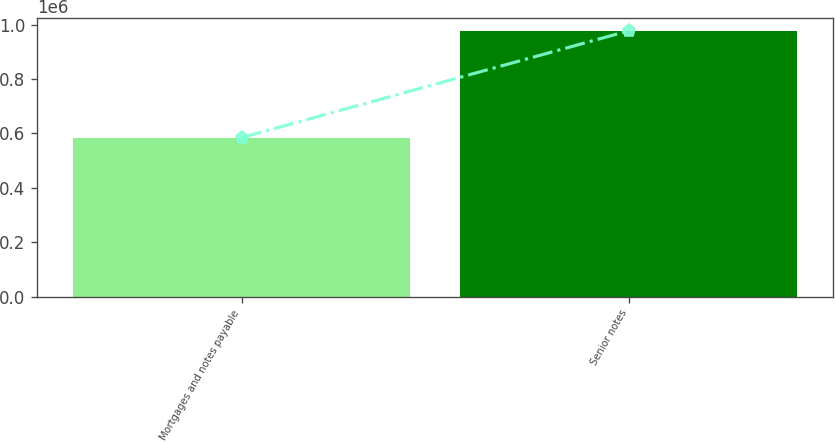Convert chart to OTSL. <chart><loc_0><loc_0><loc_500><loc_500><bar_chart><fcel>Mortgages and notes payable<fcel>Senior notes<nl><fcel>584795<fcel>977556<nl></chart> 